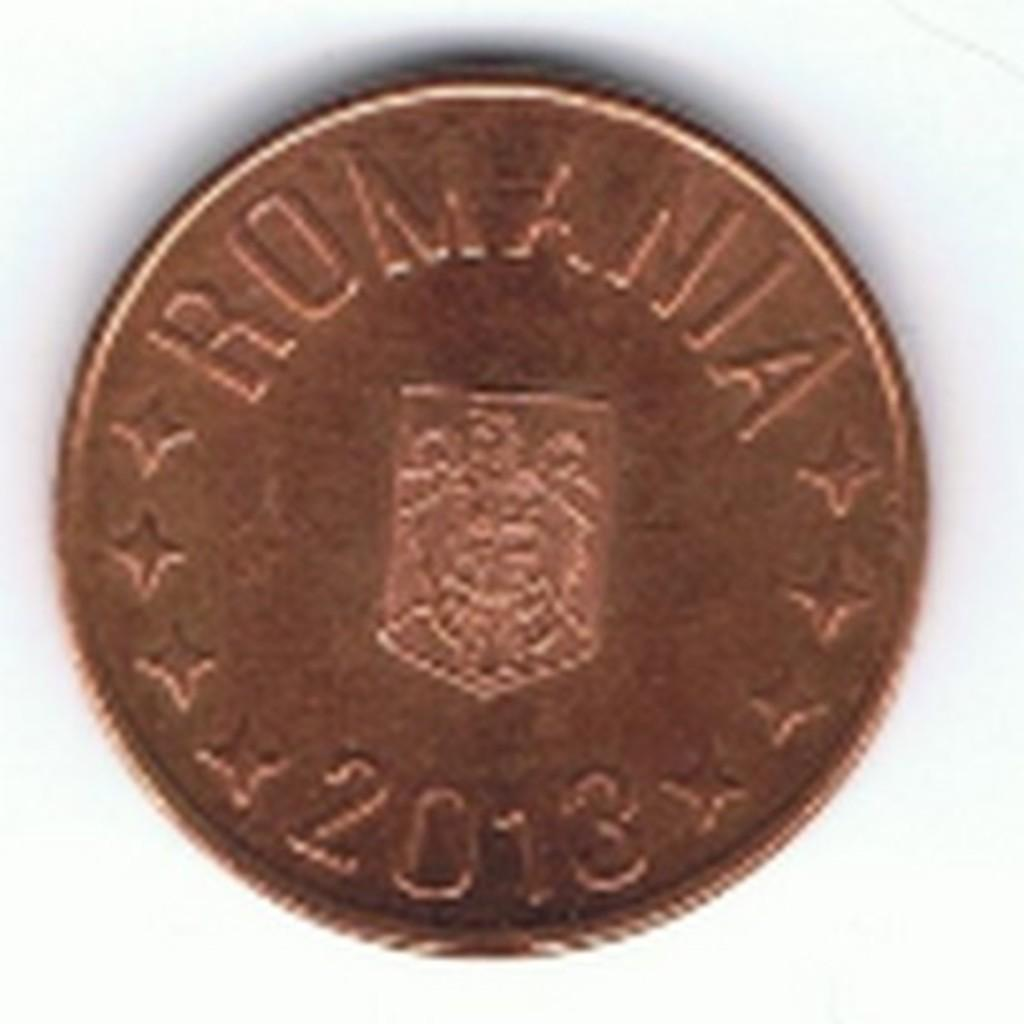<image>
Share a concise interpretation of the image provided. A gold Romania 2013 coin with three stars on each side and an emblem in the center. 